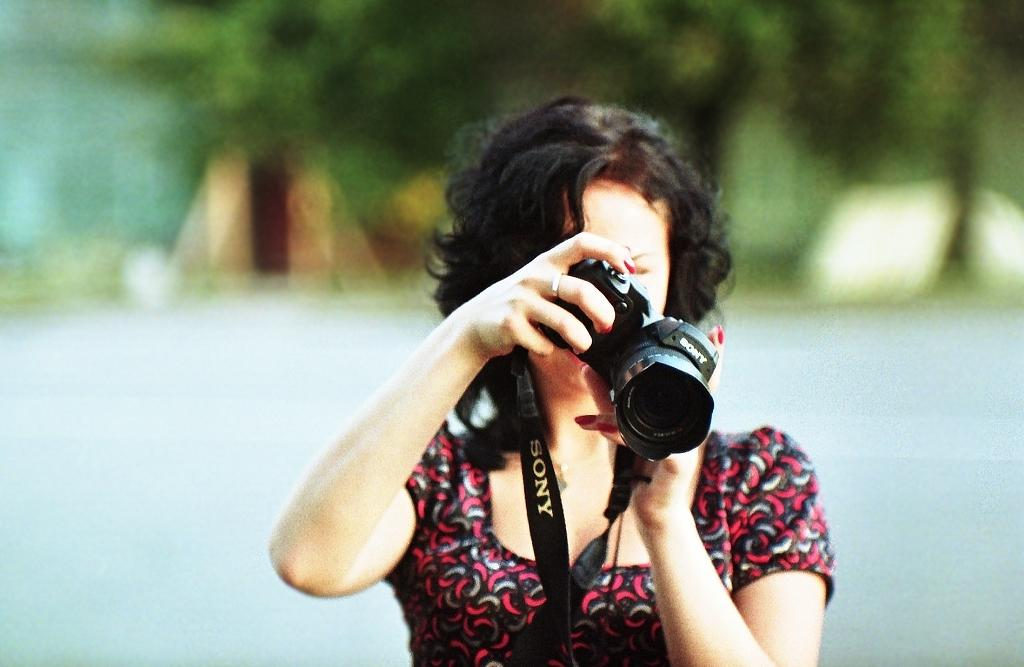Who is the main subject in the image? There is a girl in the image. What is the girl doing in the image? The girl is standing and taking a picture. What is the girl holding in the image? The girl is holding a camera. What can be seen in the background of the image? There are trees visible in the background of the image. What hobbies does the man in the image have? There is no man present in the image; it features a girl taking a picture. How many ducks are visible in the image? There are no ducks present in the image; it features a girl taking a picture with trees in the background. 